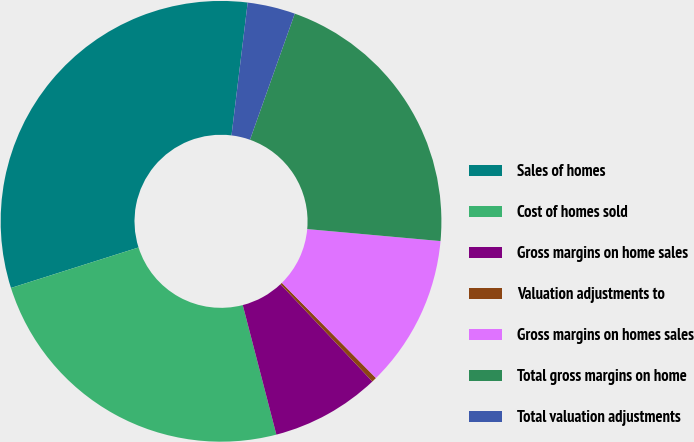Convert chart. <chart><loc_0><loc_0><loc_500><loc_500><pie_chart><fcel>Sales of homes<fcel>Cost of homes sold<fcel>Gross margins on home sales<fcel>Valuation adjustments to<fcel>Gross margins on homes sales<fcel>Total gross margins on home<fcel>Total valuation adjustments<nl><fcel>31.82%<fcel>24.15%<fcel>8.01%<fcel>0.36%<fcel>11.16%<fcel>21.0%<fcel>3.5%<nl></chart> 